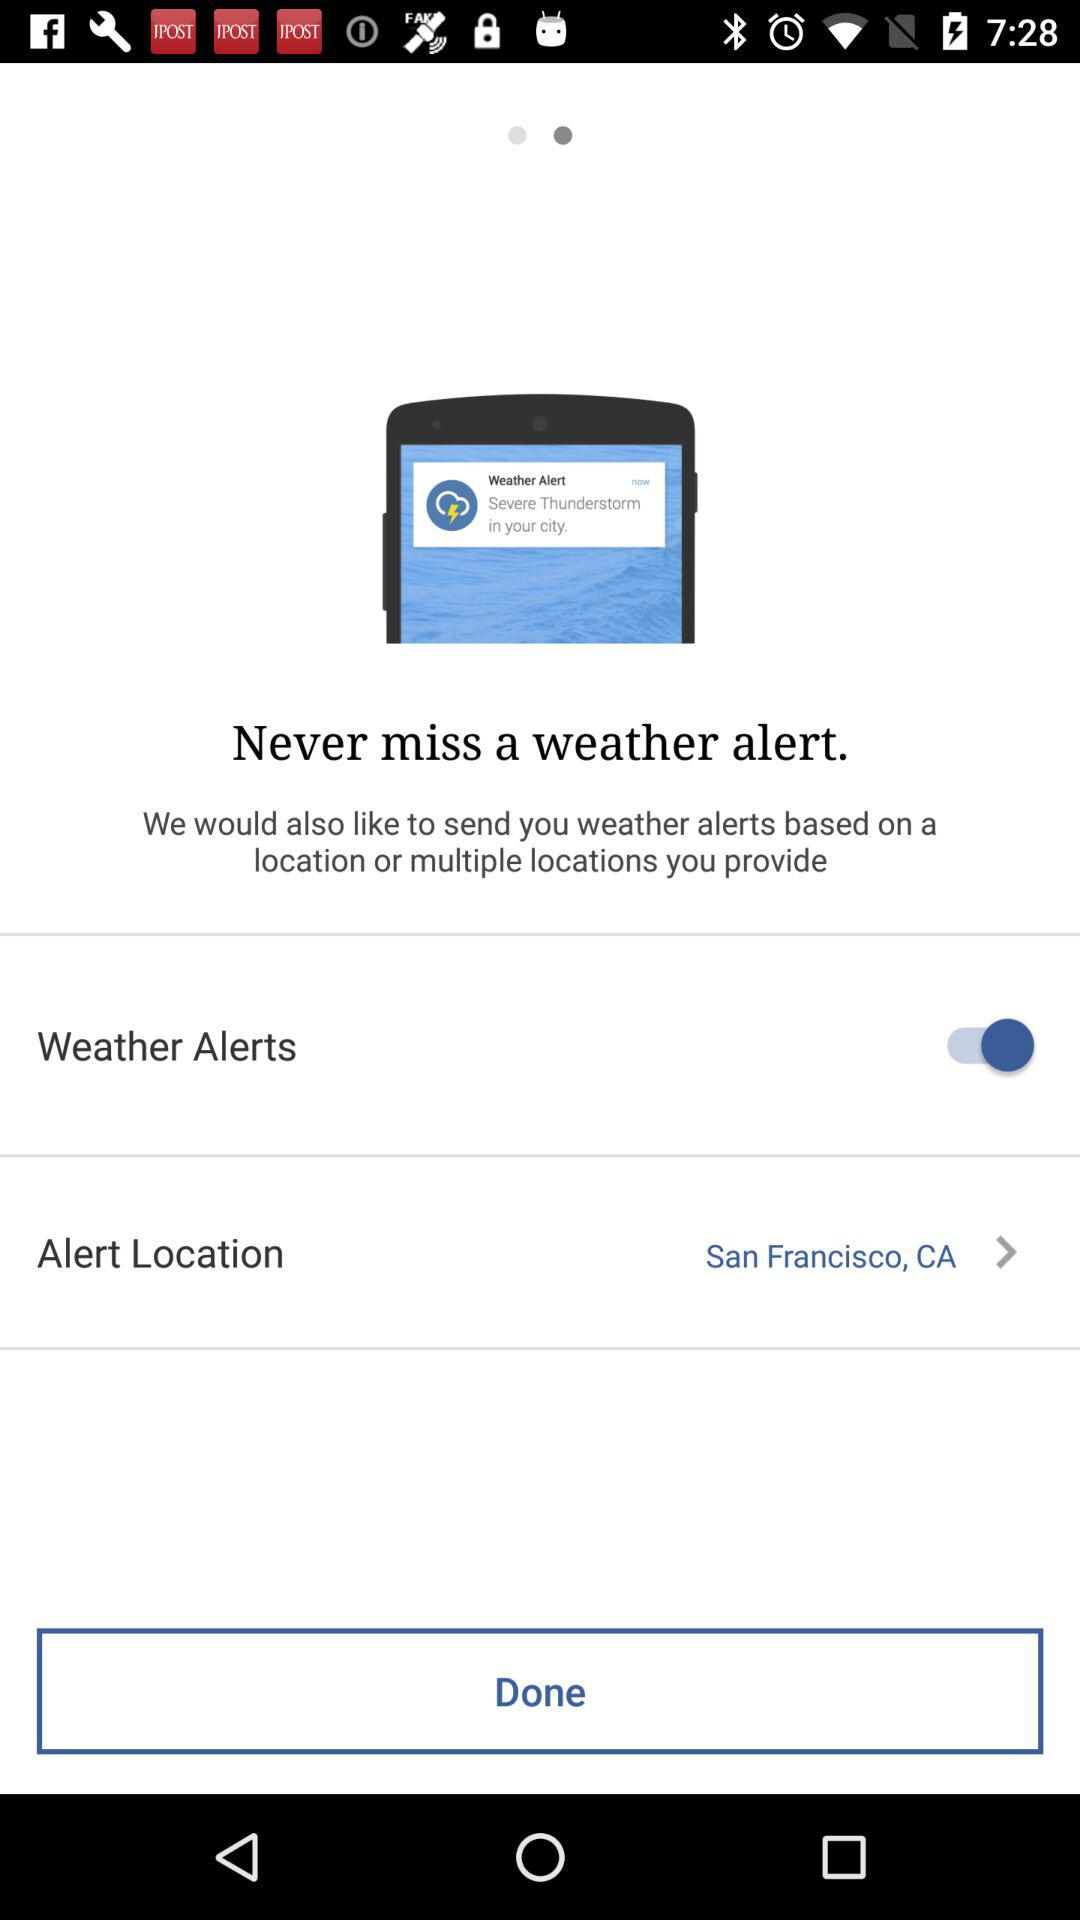What is the alert location? The alert location is San Francisco, CA. 